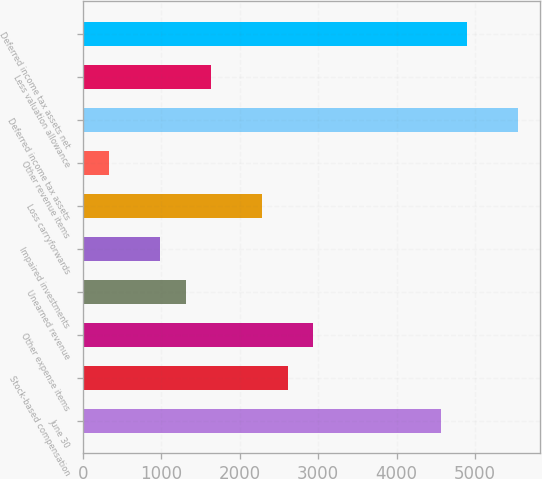Convert chart to OTSL. <chart><loc_0><loc_0><loc_500><loc_500><bar_chart><fcel>June 30<fcel>Stock-based compensation<fcel>Other expense items<fcel>Unearned revenue<fcel>Impaired investments<fcel>Loss carryforwards<fcel>Other revenue items<fcel>Deferred income tax assets<fcel>Less valuation allowance<fcel>Deferred income tax assets net<nl><fcel>4571.6<fcel>2613.2<fcel>2939.6<fcel>1307.6<fcel>981.2<fcel>2286.8<fcel>328.4<fcel>5550.8<fcel>1634<fcel>4898<nl></chart> 